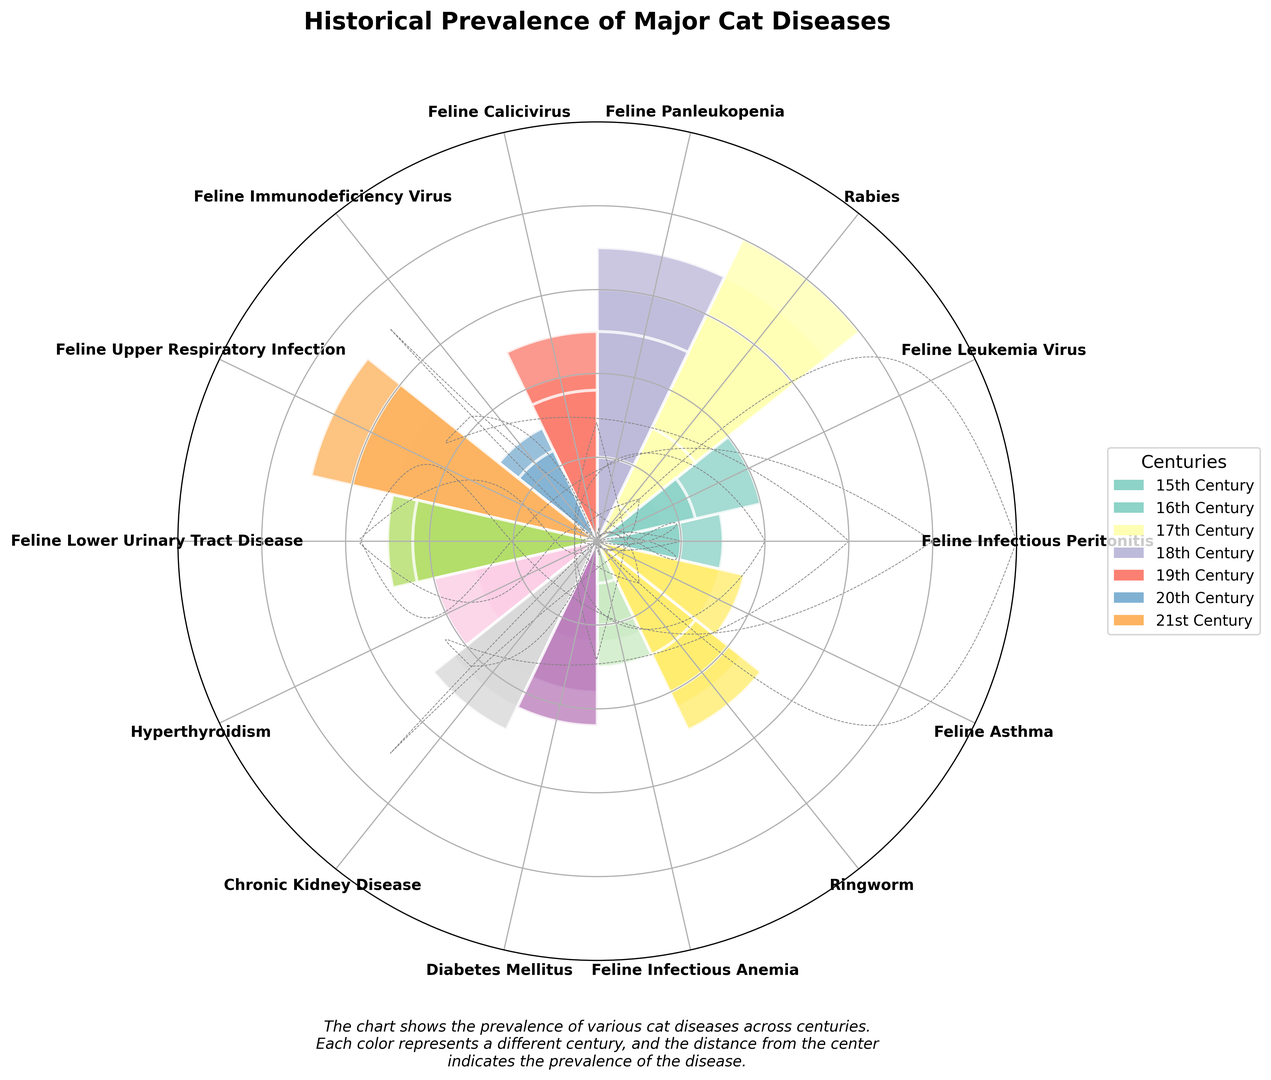What disease had the highest prevalence in the 17th century? First, identify the heights of bars representing each disease during the 17th century. Notice that "Rabies" has the highest bar, indicating the highest prevalence in that century.
Answer: Rabies Which two diseases had the same prevalence in the 15th century? Look at the bars in the 15th century and notice that "Feline Leukemia Virus" and "Feline Immunodeficiency Virus" both have bars of height 0.
Answer: Feline Leukemia Virus, Feline Immunodeficiency Virus How does the prevalence of Chronic Kidney Disease in the 20th century compare to the 21st century? Identify the height of the bars for Chronic Kidney Disease in both the 20th and 21st centuries. The height increases from the 20th (22) to the 21st (25), indicating an upward trend.
Answer: Increase What’s the average prevalence of Feline Panleukopenia from the 15th to 21st centuries? Add values across centuries: 15, 20, 25, 30, 35, 25, 10 sum to 160. Dividing by the number of centuries (7), we get 160 / 7 ≈ 22.86.
Answer: 22.86 Which disease shows a notable decrease from the 19th to the 21st century? Compare the heights of bars from the 19th to the 21st century for all diseases. "Rabies" shows a sharp decrease from 30 to 5.
Answer: Rabies Between Feline Upper Respiratory Infection and Diabetes Mellitus, which shows a higher prevalence in the 21st century? Compare the bar heights for the 21st century: Feline Upper Respiratory Infection has a height of 30, Diabetes Mellitus has a height of 22.
Answer: Feline Upper Respiratory Infection Which disease had no recorded prevalence in the 15th and 16th centuries? Identify zeros in the 15th and 16th centuries' rows. "Feline Infectious Peritonitis" has values of 0 for these centuries.
Answer: Feline Infectious Peritonitis What’s the total prevalence of Rabies over four consecutive centuries starting from the 15th century? Sum values of Rabies from the 15th to 18th centuries: 25+30+35+40 equals 130.
Answer: 130 